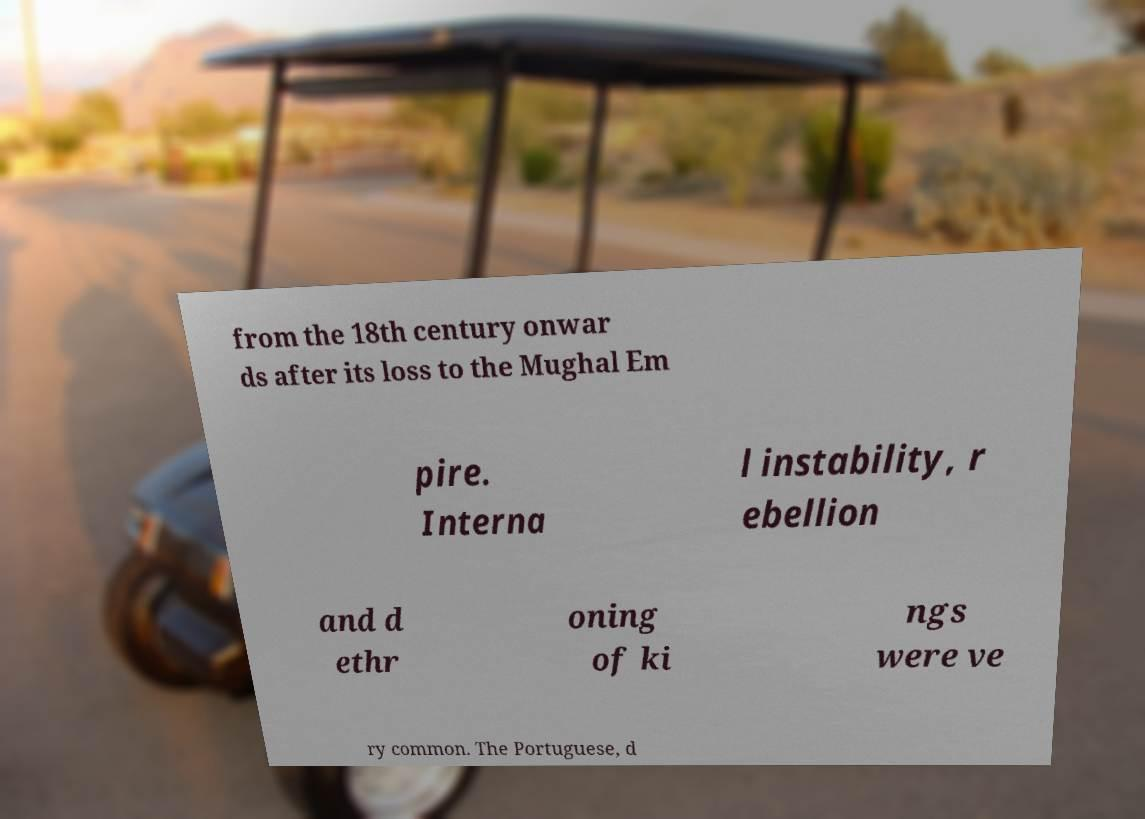I need the written content from this picture converted into text. Can you do that? from the 18th century onwar ds after its loss to the Mughal Em pire. Interna l instability, r ebellion and d ethr oning of ki ngs were ve ry common. The Portuguese, d 